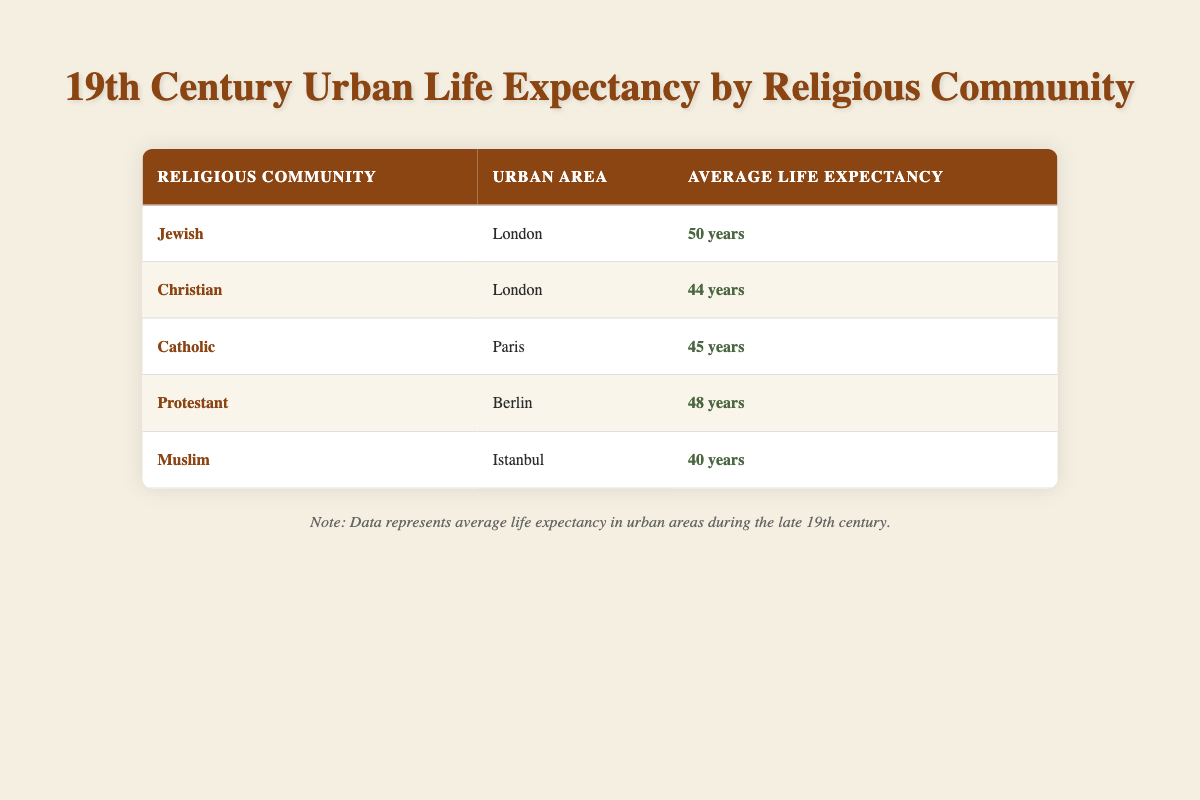What is the average life expectancy of the Jewish community in London? The table lists the average life expectancy of the Jewish community in London as 50 years.
Answer: 50 years Which religious community has the highest average life expectancy listed? According to the table, the Jewish community in London has the highest average life expectancy of 50 years.
Answer: Jewish community in London What is the difference in life expectancy between the Protestant community in Berlin and the Catholic community in Paris? The Protestant community has an average life expectancy of 48 years, while the Catholic community has 45 years. The difference is 48 - 45 = 3 years.
Answer: 3 years Is the average life expectancy of the Muslim community in Istanbul greater than that of the Christian community in London? The table shows the average life expectancy of the Muslim community as 40 years and that of the Christian community as 44 years. Therefore, 40 is not greater than 44, making the statement false.
Answer: No What is the overall average life expectancy of the communities listed in urban areas? To find the overall average, first sum the life expectancies: 50 (Jewish) + 44 (Christian) + 45 (Catholic) + 48 (Protestant) + 40 (Muslim) = 227. Then, divide by the number of communities (5): 227 / 5 = 45.4 years.
Answer: 45.4 years Does the average life expectancy of the Muslim community in Istanbul meet or exceed 40 years? The table indicates the average life expectancy of the Muslim community is exactly 40 years. Thus, it does meet this criterion, making the statement true.
Answer: Yes Which urban area has the lowest average life expectancy and what is that value? The Muslim community in Istanbul has the lowest average life expectancy at 40 years according to the table.
Answer: Istanbul, 40 years What percentage higher is the life expectancy of the Jewish community in London compared to the Muslim community in Istanbul? The life expectancy of the Jewish community is 50 years and that of the Muslim community is 40 years. The difference is 50 - 40 = 10 years. To find the percentage increase: (10 / 40) * 100 = 25%.
Answer: 25% 